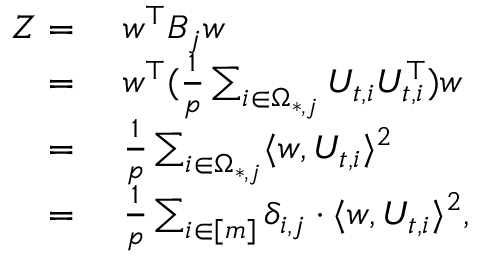Convert formula to latex. <formula><loc_0><loc_0><loc_500><loc_500>\begin{array} { r l } { Z = } & { w ^ { \top } B _ { j } w } \\ { = } & { w ^ { \top } ( \frac { 1 } { p } \sum _ { i \in \Omega _ { * , j } } U _ { t , i } U _ { t , i } ^ { \top } ) w } \\ { = } & { \frac { 1 } { p } \sum _ { i \in \Omega _ { * , j } } \langle w , U _ { t , i } \rangle ^ { 2 } } \\ { = } & { \frac { 1 } { p } \sum _ { i \in [ m ] } \delta _ { i , j } \cdot \langle w , U _ { t , i } \rangle ^ { 2 } , } \end{array}</formula> 